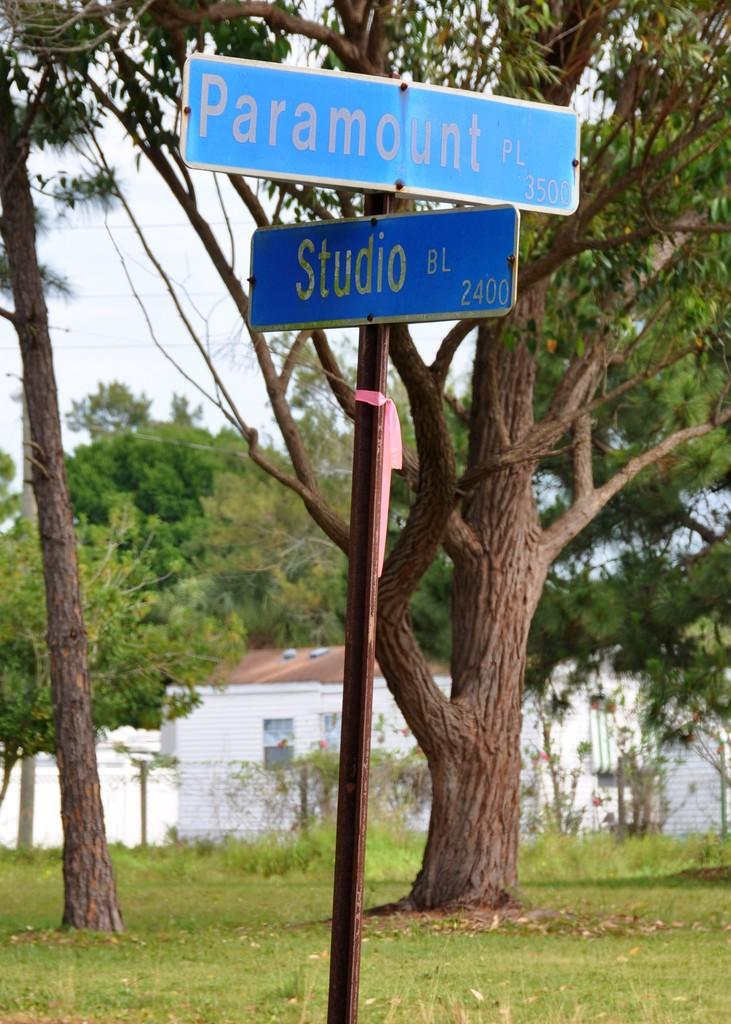What type of structure is in the picture? There is a house in the picture. What other natural elements can be seen in the picture? There are trees in the picture. Are there any man-made objects besides the house? Yes, there is a pole and a signboard in the picture. What can be seen in the sky in the picture? The sky is visible in the picture. What language is the ant speaking in the picture? There is no ant present in the picture, so it is not possible to determine what language it might be speaking. 